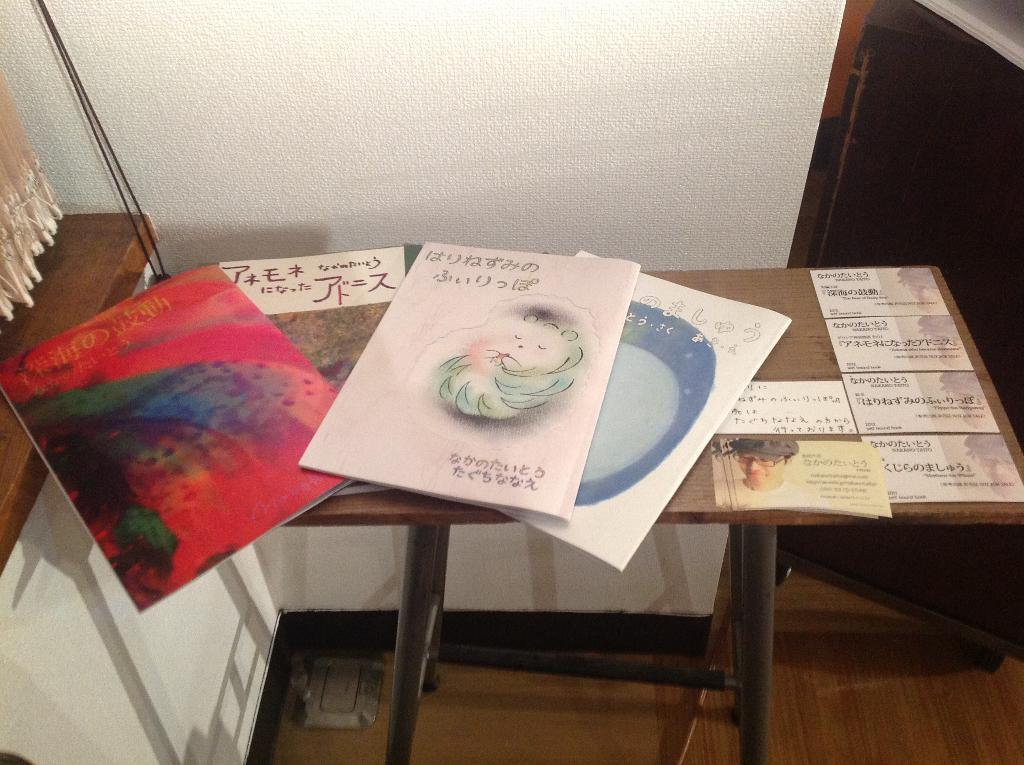What is the main piece of furniture in the image? There is a table in the image. What items can be seen on the table? There are books and notices posted on the table. What type of window treatment is visible in the image? There is a curtain on the side of the image. What other piece of furniture is visible in the image? There is a cupboard on the side of the image. What is visible in the background of the image? There is a wall in the background of the image. Can you see any sand in the image? There is no sand present in the image. How does the edge of the table look in the image? The edge of the table is not mentioned in the provided facts, so it cannot be described. 